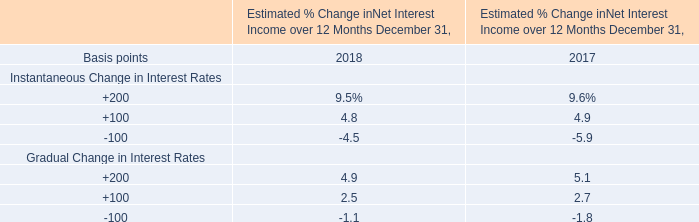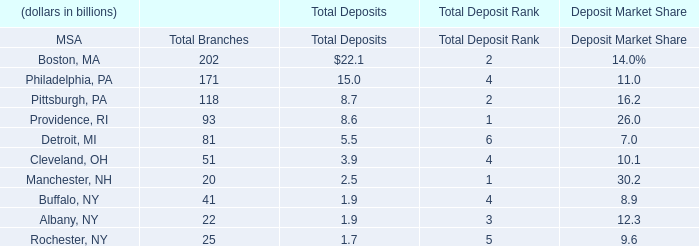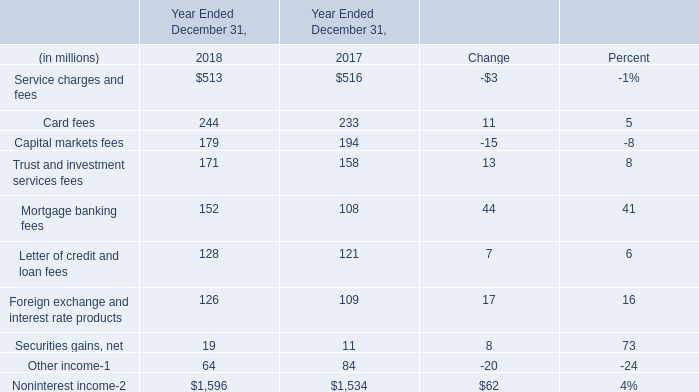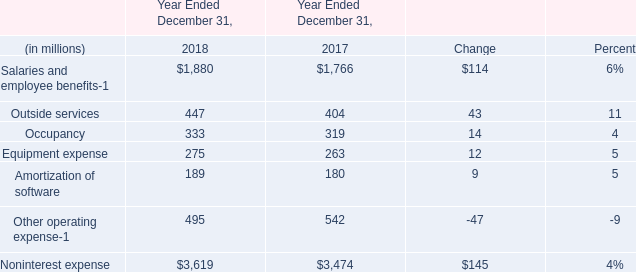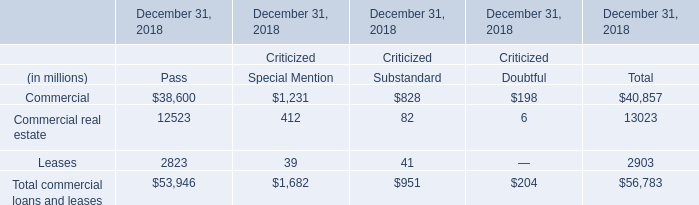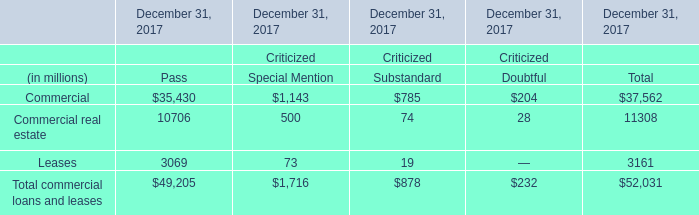What is the growing rate of Outside services in the year with the most Salaries and employee benefits? 
Computations: ((447 - 404) / 404)
Answer: 0.10644. 